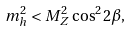<formula> <loc_0><loc_0><loc_500><loc_500>m _ { h } ^ { 2 } < M _ { Z } ^ { 2 } \cos ^ { 2 } 2 \beta ,</formula> 